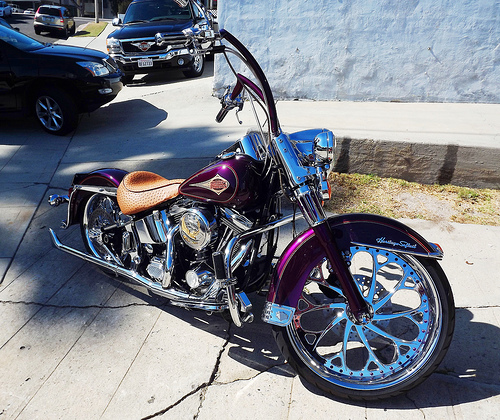<image>
Is there a pole behind the rock? Yes. From this viewpoint, the pole is positioned behind the rock, with the rock partially or fully occluding the pole. Where is the grass in relation to the motorcycle? Is it behind the motorcycle? Yes. From this viewpoint, the grass is positioned behind the motorcycle, with the motorcycle partially or fully occluding the grass. 